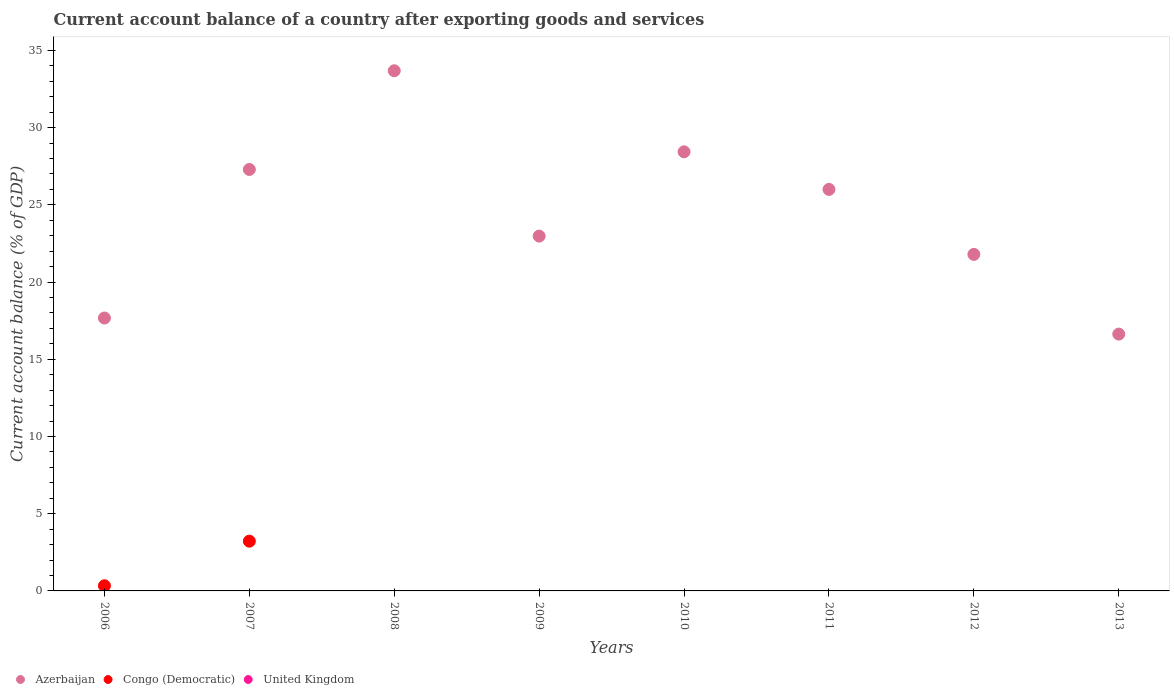How many different coloured dotlines are there?
Your answer should be compact. 2. Across all years, what is the maximum account balance in Azerbaijan?
Make the answer very short. 33.68. Across all years, what is the minimum account balance in Azerbaijan?
Make the answer very short. 16.63. In which year was the account balance in Azerbaijan maximum?
Make the answer very short. 2008. What is the difference between the account balance in Azerbaijan in 2006 and that in 2007?
Provide a succinct answer. -9.62. What is the difference between the account balance in Congo (Democratic) in 2013 and the account balance in United Kingdom in 2010?
Ensure brevity in your answer.  0. What is the average account balance in Azerbaijan per year?
Provide a succinct answer. 24.31. In the year 2007, what is the difference between the account balance in Congo (Democratic) and account balance in Azerbaijan?
Your answer should be compact. -24.07. In how many years, is the account balance in Congo (Democratic) greater than 24 %?
Provide a short and direct response. 0. What is the ratio of the account balance in Azerbaijan in 2010 to that in 2011?
Provide a short and direct response. 1.09. Is the difference between the account balance in Congo (Democratic) in 2006 and 2007 greater than the difference between the account balance in Azerbaijan in 2006 and 2007?
Your answer should be compact. Yes. What is the difference between the highest and the second highest account balance in Azerbaijan?
Offer a terse response. 5.25. What is the difference between the highest and the lowest account balance in Azerbaijan?
Offer a very short reply. 17.05. In how many years, is the account balance in Azerbaijan greater than the average account balance in Azerbaijan taken over all years?
Make the answer very short. 4. Is it the case that in every year, the sum of the account balance in Congo (Democratic) and account balance in United Kingdom  is greater than the account balance in Azerbaijan?
Ensure brevity in your answer.  No. Does the account balance in Azerbaijan monotonically increase over the years?
Make the answer very short. No. Is the account balance in United Kingdom strictly less than the account balance in Azerbaijan over the years?
Provide a succinct answer. Yes. How many dotlines are there?
Make the answer very short. 2. How many years are there in the graph?
Your response must be concise. 8. What is the difference between two consecutive major ticks on the Y-axis?
Provide a succinct answer. 5. How many legend labels are there?
Your response must be concise. 3. What is the title of the graph?
Your response must be concise. Current account balance of a country after exporting goods and services. Does "Caribbean small states" appear as one of the legend labels in the graph?
Your answer should be very brief. No. What is the label or title of the X-axis?
Your answer should be compact. Years. What is the label or title of the Y-axis?
Your answer should be very brief. Current account balance (% of GDP). What is the Current account balance (% of GDP) of Azerbaijan in 2006?
Offer a very short reply. 17.67. What is the Current account balance (% of GDP) of Congo (Democratic) in 2006?
Offer a terse response. 0.33. What is the Current account balance (% of GDP) in Azerbaijan in 2007?
Offer a very short reply. 27.29. What is the Current account balance (% of GDP) of Congo (Democratic) in 2007?
Provide a succinct answer. 3.22. What is the Current account balance (% of GDP) of United Kingdom in 2007?
Make the answer very short. 0. What is the Current account balance (% of GDP) of Azerbaijan in 2008?
Your answer should be very brief. 33.68. What is the Current account balance (% of GDP) of Azerbaijan in 2009?
Offer a very short reply. 22.97. What is the Current account balance (% of GDP) in United Kingdom in 2009?
Your answer should be compact. 0. What is the Current account balance (% of GDP) of Azerbaijan in 2010?
Provide a short and direct response. 28.43. What is the Current account balance (% of GDP) in United Kingdom in 2010?
Ensure brevity in your answer.  0. What is the Current account balance (% of GDP) of Azerbaijan in 2011?
Your answer should be very brief. 26. What is the Current account balance (% of GDP) of Congo (Democratic) in 2011?
Offer a very short reply. 0. What is the Current account balance (% of GDP) in United Kingdom in 2011?
Offer a very short reply. 0. What is the Current account balance (% of GDP) of Azerbaijan in 2012?
Offer a very short reply. 21.79. What is the Current account balance (% of GDP) in Azerbaijan in 2013?
Offer a very short reply. 16.63. Across all years, what is the maximum Current account balance (% of GDP) of Azerbaijan?
Offer a very short reply. 33.68. Across all years, what is the maximum Current account balance (% of GDP) of Congo (Democratic)?
Your answer should be compact. 3.22. Across all years, what is the minimum Current account balance (% of GDP) of Azerbaijan?
Offer a terse response. 16.63. Across all years, what is the minimum Current account balance (% of GDP) of Congo (Democratic)?
Your answer should be very brief. 0. What is the total Current account balance (% of GDP) in Azerbaijan in the graph?
Make the answer very short. 194.45. What is the total Current account balance (% of GDP) in Congo (Democratic) in the graph?
Provide a succinct answer. 3.55. What is the difference between the Current account balance (% of GDP) in Azerbaijan in 2006 and that in 2007?
Your answer should be very brief. -9.62. What is the difference between the Current account balance (% of GDP) in Congo (Democratic) in 2006 and that in 2007?
Give a very brief answer. -2.89. What is the difference between the Current account balance (% of GDP) of Azerbaijan in 2006 and that in 2008?
Your response must be concise. -16.01. What is the difference between the Current account balance (% of GDP) in Azerbaijan in 2006 and that in 2009?
Offer a very short reply. -5.3. What is the difference between the Current account balance (% of GDP) of Azerbaijan in 2006 and that in 2010?
Keep it short and to the point. -10.76. What is the difference between the Current account balance (% of GDP) of Azerbaijan in 2006 and that in 2011?
Your answer should be compact. -8.33. What is the difference between the Current account balance (% of GDP) in Azerbaijan in 2006 and that in 2012?
Keep it short and to the point. -4.12. What is the difference between the Current account balance (% of GDP) in Azerbaijan in 2006 and that in 2013?
Provide a succinct answer. 1.04. What is the difference between the Current account balance (% of GDP) in Azerbaijan in 2007 and that in 2008?
Provide a short and direct response. -6.39. What is the difference between the Current account balance (% of GDP) in Azerbaijan in 2007 and that in 2009?
Provide a succinct answer. 4.32. What is the difference between the Current account balance (% of GDP) in Azerbaijan in 2007 and that in 2010?
Keep it short and to the point. -1.14. What is the difference between the Current account balance (% of GDP) in Azerbaijan in 2007 and that in 2011?
Offer a terse response. 1.29. What is the difference between the Current account balance (% of GDP) of Azerbaijan in 2007 and that in 2012?
Provide a succinct answer. 5.5. What is the difference between the Current account balance (% of GDP) of Azerbaijan in 2007 and that in 2013?
Give a very brief answer. 10.66. What is the difference between the Current account balance (% of GDP) in Azerbaijan in 2008 and that in 2009?
Your answer should be compact. 10.71. What is the difference between the Current account balance (% of GDP) in Azerbaijan in 2008 and that in 2010?
Your answer should be very brief. 5.25. What is the difference between the Current account balance (% of GDP) in Azerbaijan in 2008 and that in 2011?
Offer a terse response. 7.68. What is the difference between the Current account balance (% of GDP) in Azerbaijan in 2008 and that in 2012?
Offer a very short reply. 11.89. What is the difference between the Current account balance (% of GDP) of Azerbaijan in 2008 and that in 2013?
Your response must be concise. 17.05. What is the difference between the Current account balance (% of GDP) in Azerbaijan in 2009 and that in 2010?
Your answer should be very brief. -5.46. What is the difference between the Current account balance (% of GDP) of Azerbaijan in 2009 and that in 2011?
Offer a very short reply. -3.02. What is the difference between the Current account balance (% of GDP) of Azerbaijan in 2009 and that in 2012?
Offer a terse response. 1.18. What is the difference between the Current account balance (% of GDP) of Azerbaijan in 2009 and that in 2013?
Your response must be concise. 6.34. What is the difference between the Current account balance (% of GDP) of Azerbaijan in 2010 and that in 2011?
Offer a very short reply. 2.43. What is the difference between the Current account balance (% of GDP) in Azerbaijan in 2010 and that in 2012?
Provide a short and direct response. 6.64. What is the difference between the Current account balance (% of GDP) in Azerbaijan in 2010 and that in 2013?
Your answer should be very brief. 11.8. What is the difference between the Current account balance (% of GDP) in Azerbaijan in 2011 and that in 2012?
Your response must be concise. 4.21. What is the difference between the Current account balance (% of GDP) in Azerbaijan in 2011 and that in 2013?
Give a very brief answer. 9.37. What is the difference between the Current account balance (% of GDP) in Azerbaijan in 2012 and that in 2013?
Make the answer very short. 5.16. What is the difference between the Current account balance (% of GDP) of Azerbaijan in 2006 and the Current account balance (% of GDP) of Congo (Democratic) in 2007?
Offer a very short reply. 14.45. What is the average Current account balance (% of GDP) of Azerbaijan per year?
Offer a very short reply. 24.31. What is the average Current account balance (% of GDP) of Congo (Democratic) per year?
Provide a succinct answer. 0.44. What is the average Current account balance (% of GDP) of United Kingdom per year?
Your answer should be very brief. 0. In the year 2006, what is the difference between the Current account balance (% of GDP) in Azerbaijan and Current account balance (% of GDP) in Congo (Democratic)?
Keep it short and to the point. 17.34. In the year 2007, what is the difference between the Current account balance (% of GDP) of Azerbaijan and Current account balance (% of GDP) of Congo (Democratic)?
Offer a very short reply. 24.07. What is the ratio of the Current account balance (% of GDP) in Azerbaijan in 2006 to that in 2007?
Give a very brief answer. 0.65. What is the ratio of the Current account balance (% of GDP) of Congo (Democratic) in 2006 to that in 2007?
Provide a short and direct response. 0.1. What is the ratio of the Current account balance (% of GDP) of Azerbaijan in 2006 to that in 2008?
Offer a very short reply. 0.52. What is the ratio of the Current account balance (% of GDP) of Azerbaijan in 2006 to that in 2009?
Your answer should be compact. 0.77. What is the ratio of the Current account balance (% of GDP) of Azerbaijan in 2006 to that in 2010?
Give a very brief answer. 0.62. What is the ratio of the Current account balance (% of GDP) of Azerbaijan in 2006 to that in 2011?
Provide a succinct answer. 0.68. What is the ratio of the Current account balance (% of GDP) in Azerbaijan in 2006 to that in 2012?
Ensure brevity in your answer.  0.81. What is the ratio of the Current account balance (% of GDP) of Azerbaijan in 2006 to that in 2013?
Provide a short and direct response. 1.06. What is the ratio of the Current account balance (% of GDP) of Azerbaijan in 2007 to that in 2008?
Provide a short and direct response. 0.81. What is the ratio of the Current account balance (% of GDP) in Azerbaijan in 2007 to that in 2009?
Your answer should be compact. 1.19. What is the ratio of the Current account balance (% of GDP) of Azerbaijan in 2007 to that in 2010?
Keep it short and to the point. 0.96. What is the ratio of the Current account balance (% of GDP) in Azerbaijan in 2007 to that in 2011?
Offer a very short reply. 1.05. What is the ratio of the Current account balance (% of GDP) of Azerbaijan in 2007 to that in 2012?
Your answer should be very brief. 1.25. What is the ratio of the Current account balance (% of GDP) in Azerbaijan in 2007 to that in 2013?
Offer a terse response. 1.64. What is the ratio of the Current account balance (% of GDP) of Azerbaijan in 2008 to that in 2009?
Give a very brief answer. 1.47. What is the ratio of the Current account balance (% of GDP) in Azerbaijan in 2008 to that in 2010?
Provide a short and direct response. 1.18. What is the ratio of the Current account balance (% of GDP) of Azerbaijan in 2008 to that in 2011?
Your answer should be compact. 1.3. What is the ratio of the Current account balance (% of GDP) of Azerbaijan in 2008 to that in 2012?
Offer a very short reply. 1.55. What is the ratio of the Current account balance (% of GDP) in Azerbaijan in 2008 to that in 2013?
Your answer should be very brief. 2.03. What is the ratio of the Current account balance (% of GDP) of Azerbaijan in 2009 to that in 2010?
Your answer should be very brief. 0.81. What is the ratio of the Current account balance (% of GDP) of Azerbaijan in 2009 to that in 2011?
Your response must be concise. 0.88. What is the ratio of the Current account balance (% of GDP) in Azerbaijan in 2009 to that in 2012?
Your answer should be compact. 1.05. What is the ratio of the Current account balance (% of GDP) of Azerbaijan in 2009 to that in 2013?
Your answer should be very brief. 1.38. What is the ratio of the Current account balance (% of GDP) in Azerbaijan in 2010 to that in 2011?
Give a very brief answer. 1.09. What is the ratio of the Current account balance (% of GDP) of Azerbaijan in 2010 to that in 2012?
Your answer should be compact. 1.3. What is the ratio of the Current account balance (% of GDP) of Azerbaijan in 2010 to that in 2013?
Provide a short and direct response. 1.71. What is the ratio of the Current account balance (% of GDP) of Azerbaijan in 2011 to that in 2012?
Offer a very short reply. 1.19. What is the ratio of the Current account balance (% of GDP) of Azerbaijan in 2011 to that in 2013?
Ensure brevity in your answer.  1.56. What is the ratio of the Current account balance (% of GDP) of Azerbaijan in 2012 to that in 2013?
Your answer should be compact. 1.31. What is the difference between the highest and the second highest Current account balance (% of GDP) in Azerbaijan?
Your answer should be compact. 5.25. What is the difference between the highest and the lowest Current account balance (% of GDP) of Azerbaijan?
Keep it short and to the point. 17.05. What is the difference between the highest and the lowest Current account balance (% of GDP) in Congo (Democratic)?
Your answer should be compact. 3.22. 